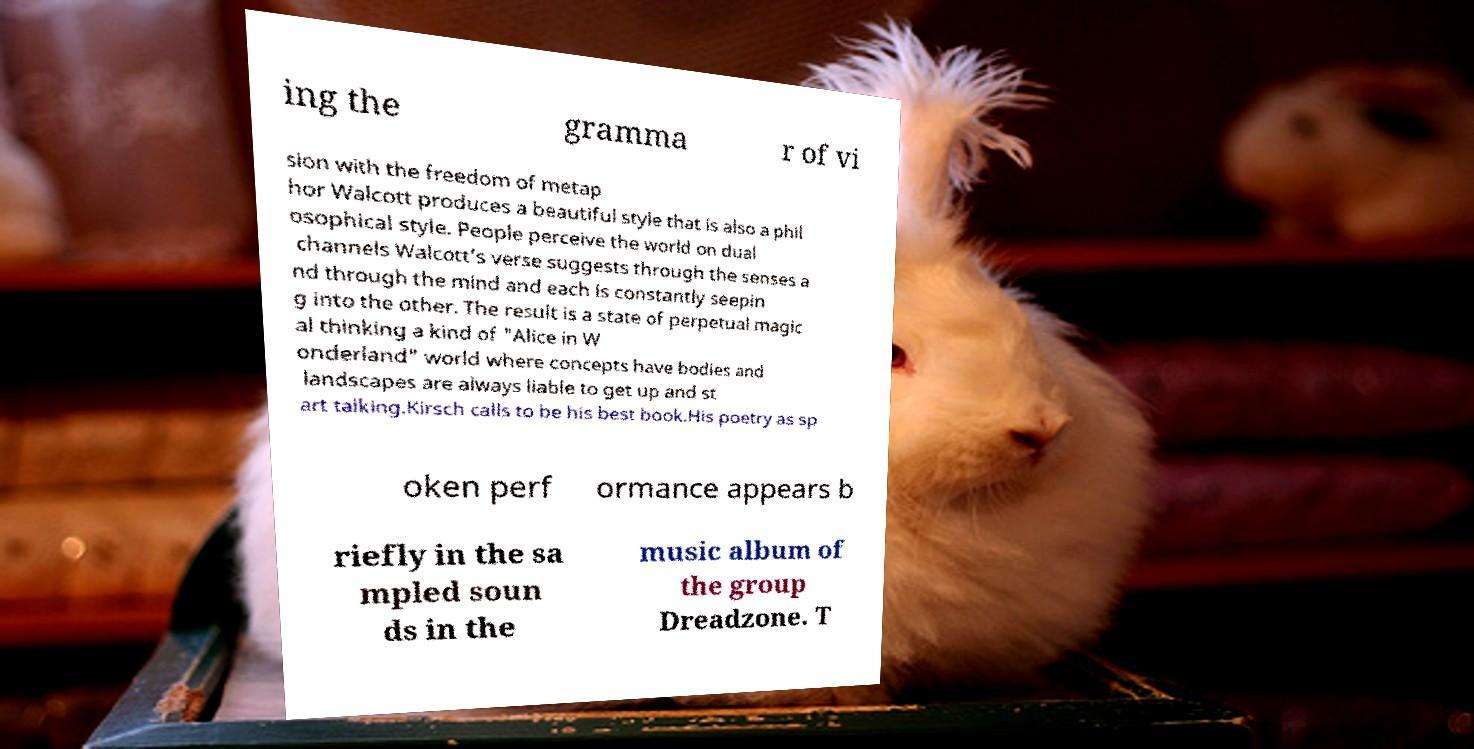Can you read and provide the text displayed in the image?This photo seems to have some interesting text. Can you extract and type it out for me? ing the gramma r of vi sion with the freedom of metap hor Walcott produces a beautiful style that is also a phil osophical style. People perceive the world on dual channels Walcott’s verse suggests through the senses a nd through the mind and each is constantly seepin g into the other. The result is a state of perpetual magic al thinking a kind of "Alice in W onderland" world where concepts have bodies and landscapes are always liable to get up and st art talking.Kirsch calls to be his best book.His poetry as sp oken perf ormance appears b riefly in the sa mpled soun ds in the music album of the group Dreadzone. T 